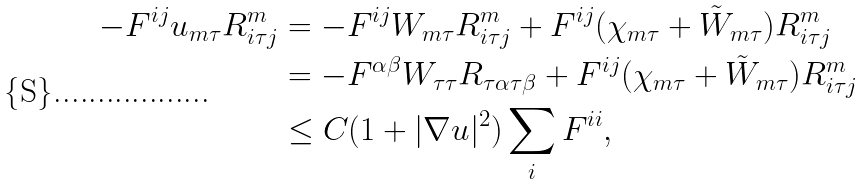Convert formula to latex. <formula><loc_0><loc_0><loc_500><loc_500>- F ^ { i j } u _ { m \tau } R ^ { m } _ { i \tau j } & = - F ^ { i j } W _ { m \tau } R ^ { m } _ { i \tau j } + F ^ { i j } ( \chi _ { m \tau } + \tilde { W } _ { m \tau } ) R ^ { m } _ { i \tau j } \\ & = - F ^ { \alpha \beta } W _ { \tau \tau } R _ { \tau \alpha \tau \beta } + F ^ { i j } ( \chi _ { m \tau } + \tilde { W } _ { m \tau } ) R ^ { m } _ { i \tau j } \\ & \leq C ( 1 + | \nabla u | ^ { 2 } ) \sum _ { i } F ^ { i i } ,</formula> 